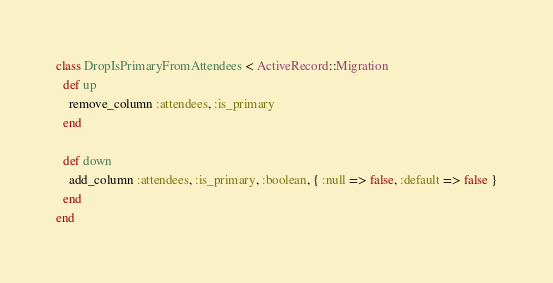<code> <loc_0><loc_0><loc_500><loc_500><_Ruby_>class DropIsPrimaryFromAttendees < ActiveRecord::Migration
  def up
    remove_column :attendees, :is_primary
  end

  def down
    add_column :attendees, :is_primary, :boolean, { :null => false, :default => false }
  end
end
</code> 